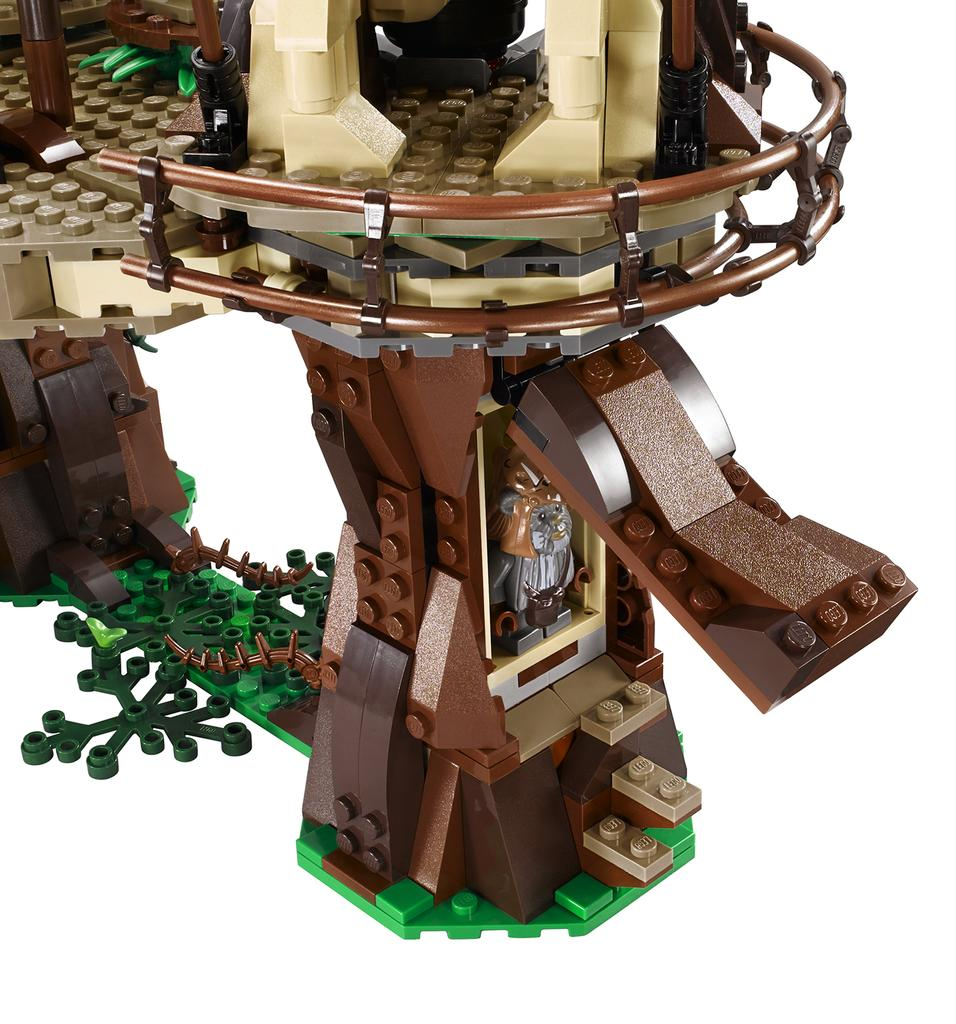What type of toy is in the image? There is a toy made up of building blocks in the image. What can be seen in the background of the image? The background of the image is white. What type of dress is the dad wearing in the image? There is no dad or dress present in the image. 